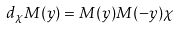<formula> <loc_0><loc_0><loc_500><loc_500>d _ { \chi } M ( y ) = M ( y ) M ( - y ) \chi</formula> 